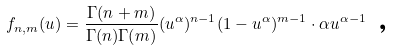<formula> <loc_0><loc_0><loc_500><loc_500>f _ { n , m } ( u ) = \frac { \Gamma ( n + m ) } { \Gamma ( n ) \Gamma ( m ) } ( u ^ { \alpha } ) ^ { n - 1 } ( 1 - u ^ { \alpha } ) ^ { m - 1 } \cdot \alpha u ^ { \alpha - 1 } \text { ,}</formula> 